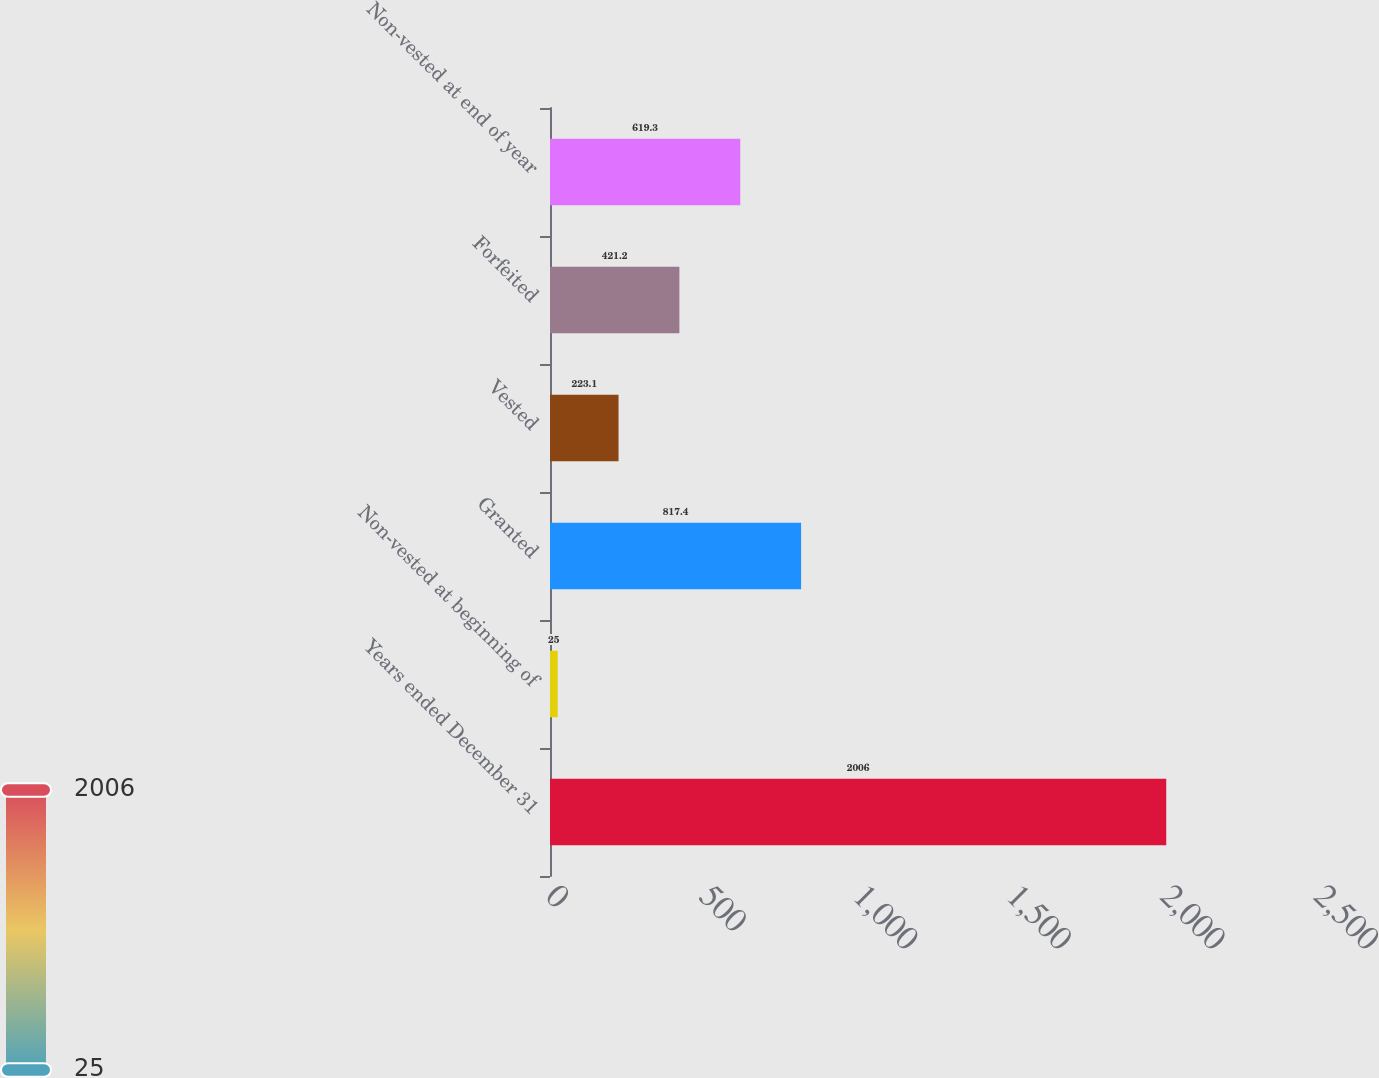Convert chart. <chart><loc_0><loc_0><loc_500><loc_500><bar_chart><fcel>Years ended December 31<fcel>Non-vested at beginning of<fcel>Granted<fcel>Vested<fcel>Forfeited<fcel>Non-vested at end of year<nl><fcel>2006<fcel>25<fcel>817.4<fcel>223.1<fcel>421.2<fcel>619.3<nl></chart> 